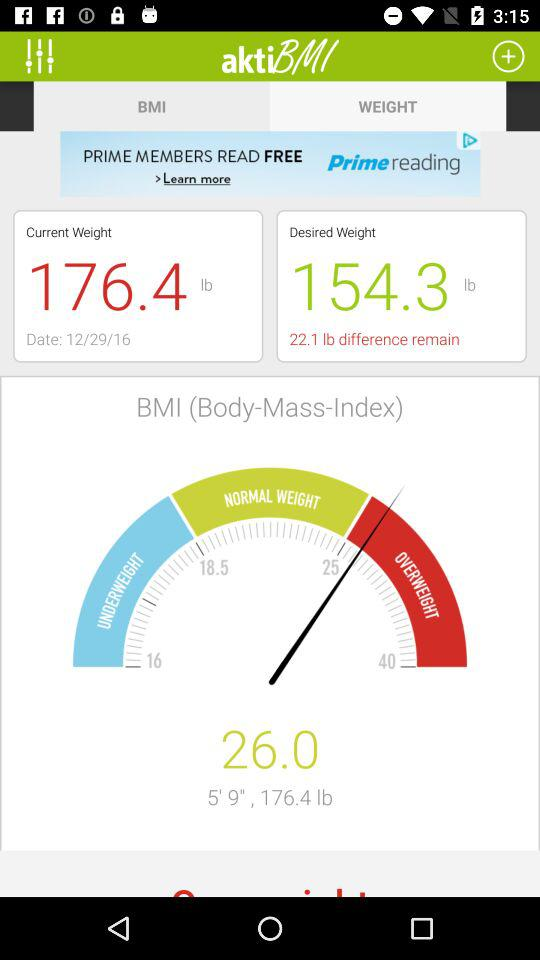How much weight do I need to lose to reach my desired weight?
Answer the question using a single word or phrase. 22.1 lb 